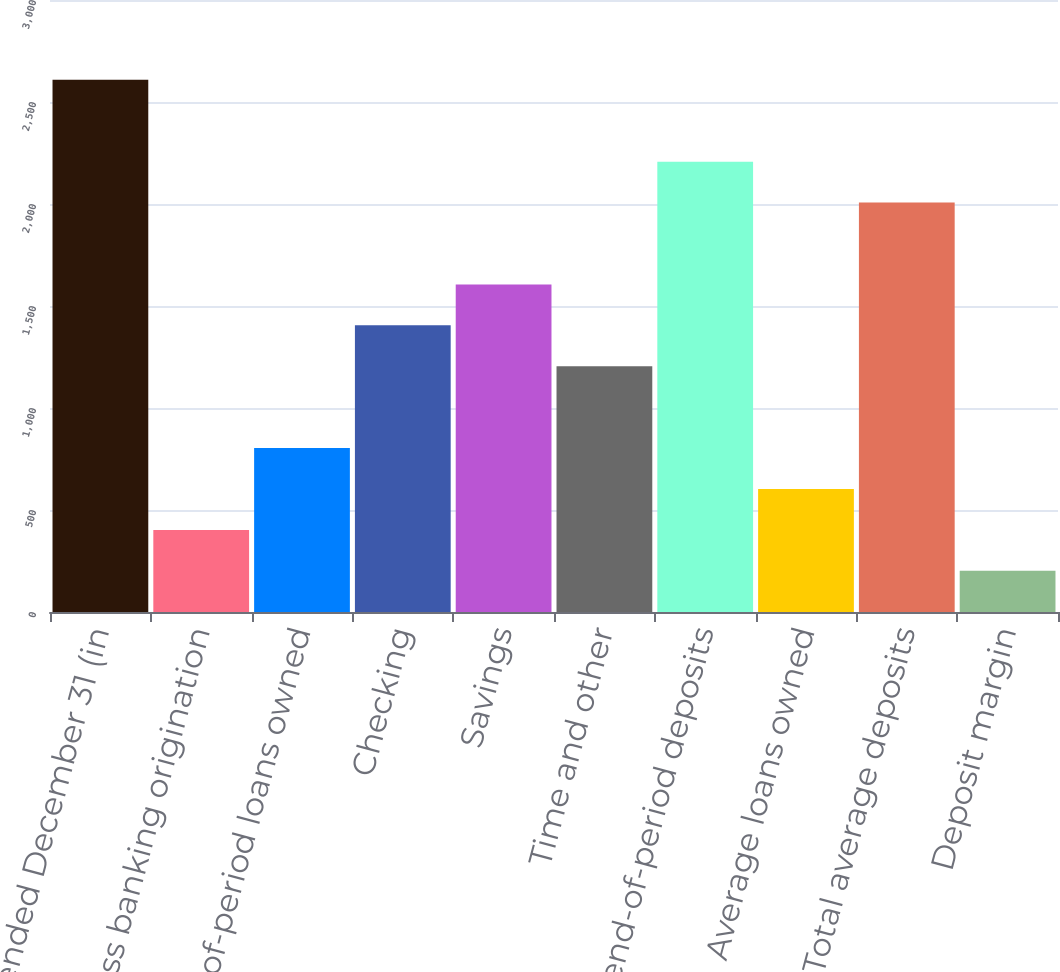<chart> <loc_0><loc_0><loc_500><loc_500><bar_chart><fcel>Year ended December 31 (in<fcel>Business banking origination<fcel>End-of-period loans owned<fcel>Checking<fcel>Savings<fcel>Time and other<fcel>Total end-of-period deposits<fcel>Average loans owned<fcel>Total average deposits<fcel>Deposit margin<nl><fcel>2608.76<fcel>402.27<fcel>803.45<fcel>1405.22<fcel>1605.81<fcel>1204.63<fcel>2207.58<fcel>602.86<fcel>2006.99<fcel>201.68<nl></chart> 